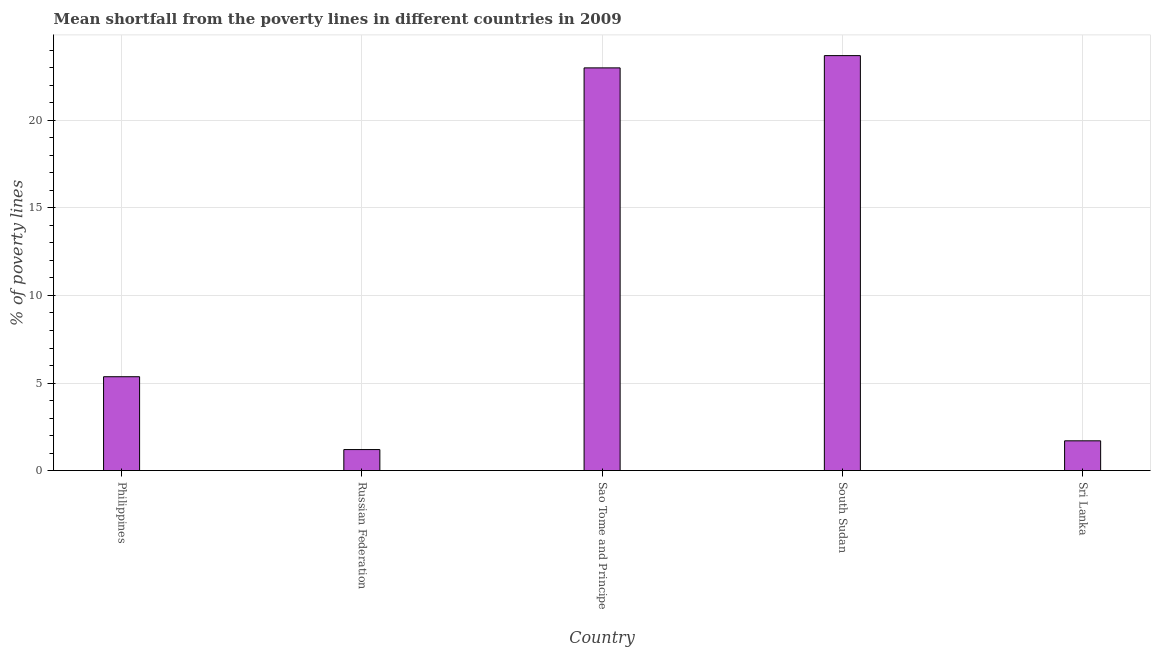What is the title of the graph?
Your answer should be very brief. Mean shortfall from the poverty lines in different countries in 2009. What is the label or title of the X-axis?
Make the answer very short. Country. What is the label or title of the Y-axis?
Ensure brevity in your answer.  % of poverty lines. Across all countries, what is the maximum poverty gap at national poverty lines?
Your response must be concise. 23.7. Across all countries, what is the minimum poverty gap at national poverty lines?
Provide a short and direct response. 1.2. In which country was the poverty gap at national poverty lines maximum?
Offer a terse response. South Sudan. In which country was the poverty gap at national poverty lines minimum?
Provide a succinct answer. Russian Federation. What is the sum of the poverty gap at national poverty lines?
Your response must be concise. 54.96. What is the difference between the poverty gap at national poverty lines in Russian Federation and South Sudan?
Your answer should be compact. -22.5. What is the average poverty gap at national poverty lines per country?
Offer a terse response. 10.99. What is the median poverty gap at national poverty lines?
Keep it short and to the point. 5.36. What is the ratio of the poverty gap at national poverty lines in South Sudan to that in Sri Lanka?
Provide a short and direct response. 13.94. Are all the bars in the graph horizontal?
Offer a very short reply. No. What is the difference between two consecutive major ticks on the Y-axis?
Provide a succinct answer. 5. What is the % of poverty lines in Philippines?
Your response must be concise. 5.36. What is the % of poverty lines in Russian Federation?
Your answer should be very brief. 1.2. What is the % of poverty lines in South Sudan?
Your response must be concise. 23.7. What is the % of poverty lines in Sri Lanka?
Offer a very short reply. 1.7. What is the difference between the % of poverty lines in Philippines and Russian Federation?
Offer a very short reply. 4.16. What is the difference between the % of poverty lines in Philippines and Sao Tome and Principe?
Your answer should be very brief. -17.64. What is the difference between the % of poverty lines in Philippines and South Sudan?
Provide a succinct answer. -18.34. What is the difference between the % of poverty lines in Philippines and Sri Lanka?
Make the answer very short. 3.66. What is the difference between the % of poverty lines in Russian Federation and Sao Tome and Principe?
Your answer should be compact. -21.8. What is the difference between the % of poverty lines in Russian Federation and South Sudan?
Your answer should be very brief. -22.5. What is the difference between the % of poverty lines in Sao Tome and Principe and South Sudan?
Offer a very short reply. -0.7. What is the difference between the % of poverty lines in Sao Tome and Principe and Sri Lanka?
Provide a succinct answer. 21.3. What is the ratio of the % of poverty lines in Philippines to that in Russian Federation?
Your answer should be very brief. 4.47. What is the ratio of the % of poverty lines in Philippines to that in Sao Tome and Principe?
Keep it short and to the point. 0.23. What is the ratio of the % of poverty lines in Philippines to that in South Sudan?
Your answer should be very brief. 0.23. What is the ratio of the % of poverty lines in Philippines to that in Sri Lanka?
Your answer should be very brief. 3.15. What is the ratio of the % of poverty lines in Russian Federation to that in Sao Tome and Principe?
Provide a short and direct response. 0.05. What is the ratio of the % of poverty lines in Russian Federation to that in South Sudan?
Provide a short and direct response. 0.05. What is the ratio of the % of poverty lines in Russian Federation to that in Sri Lanka?
Provide a succinct answer. 0.71. What is the ratio of the % of poverty lines in Sao Tome and Principe to that in South Sudan?
Keep it short and to the point. 0.97. What is the ratio of the % of poverty lines in Sao Tome and Principe to that in Sri Lanka?
Your answer should be compact. 13.53. What is the ratio of the % of poverty lines in South Sudan to that in Sri Lanka?
Your response must be concise. 13.94. 